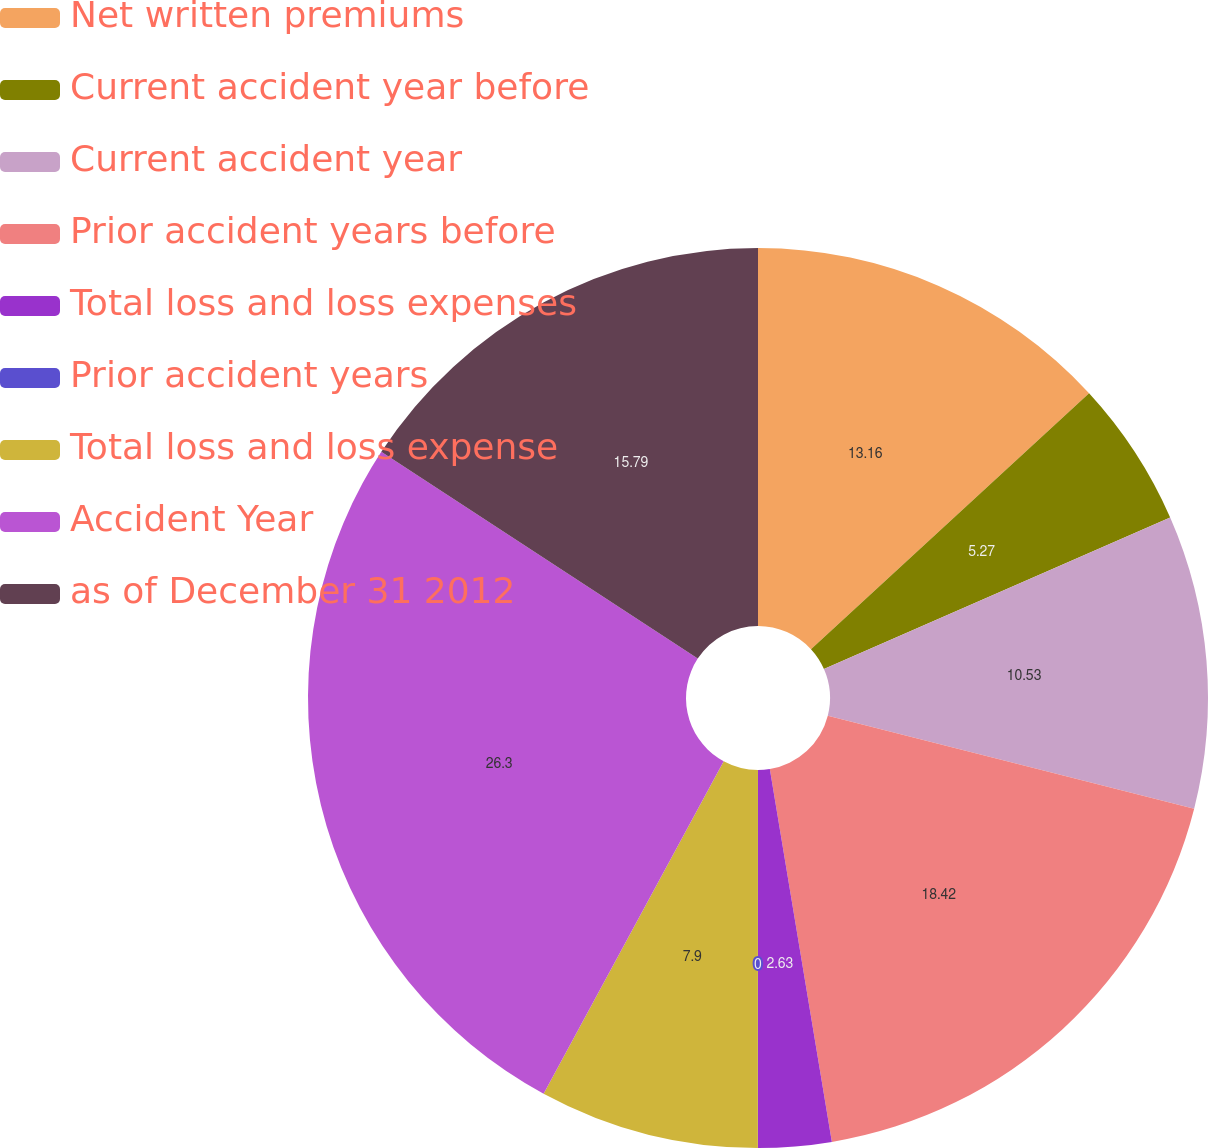Convert chart. <chart><loc_0><loc_0><loc_500><loc_500><pie_chart><fcel>Net written premiums<fcel>Current accident year before<fcel>Current accident year<fcel>Prior accident years before<fcel>Total loss and loss expenses<fcel>Prior accident years<fcel>Total loss and loss expense<fcel>Accident Year<fcel>as of December 31 2012<nl><fcel>13.16%<fcel>5.27%<fcel>10.53%<fcel>18.42%<fcel>2.63%<fcel>0.0%<fcel>7.9%<fcel>26.31%<fcel>15.79%<nl></chart> 